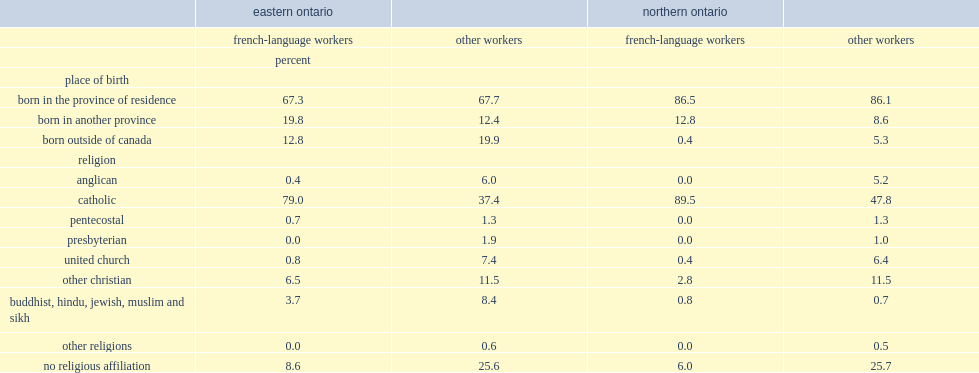In 2011, what percent of french-language workers in the agri-food sector were catholic in eastern ontario, and in northern ontario respectively? 79 89.5. 